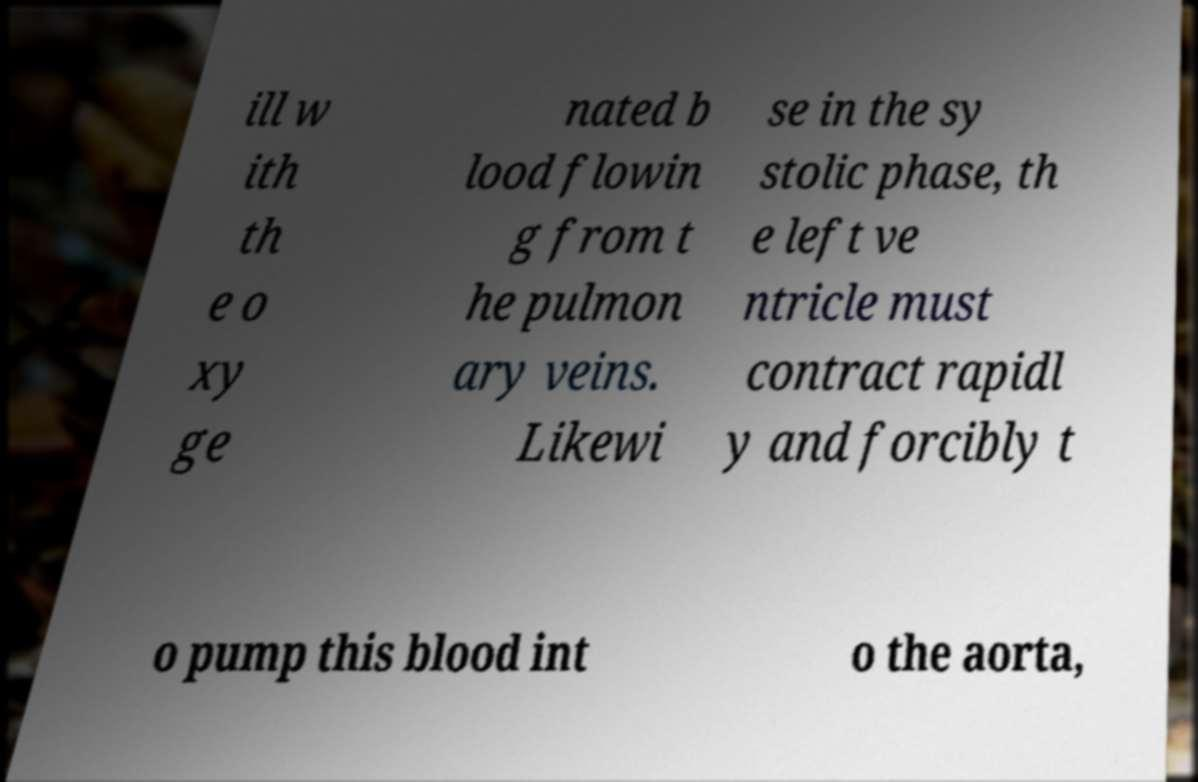What messages or text are displayed in this image? I need them in a readable, typed format. ill w ith th e o xy ge nated b lood flowin g from t he pulmon ary veins. Likewi se in the sy stolic phase, th e left ve ntricle must contract rapidl y and forcibly t o pump this blood int o the aorta, 